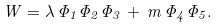<formula> <loc_0><loc_0><loc_500><loc_500>W = \lambda \, \Phi _ { 1 } \Phi _ { 2 } \Phi _ { 3 } \, + \, m \, \Phi _ { 4 } \Phi _ { 5 } .</formula> 